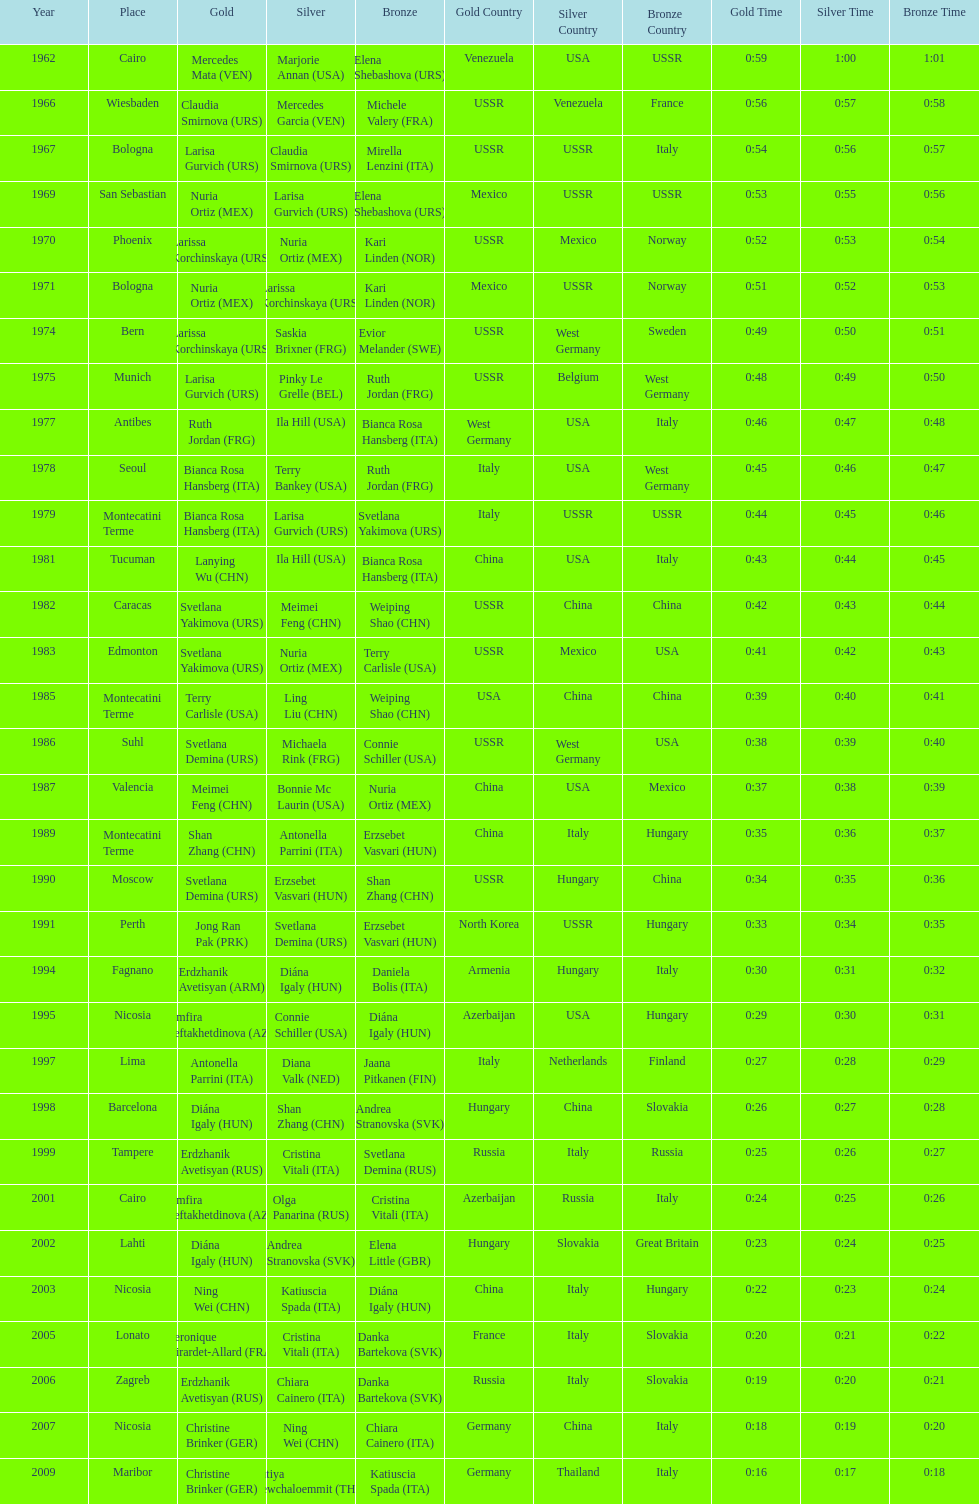What is the total of silver for cairo 0. 